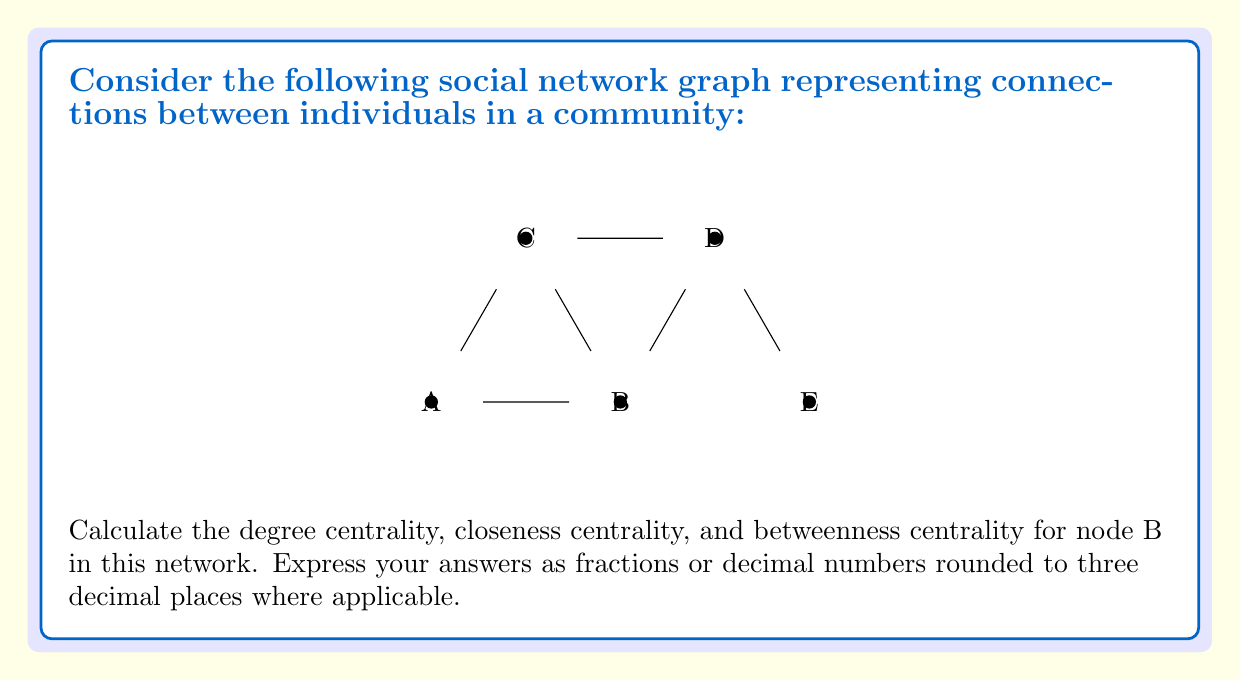Solve this math problem. To calculate the centrality measures for node B, we'll follow these steps:

1. Degree Centrality:
   Degree centrality is the number of direct connections a node has.
   Node B has 3 connections (to A, C, and D).
   Degree centrality = 3
   Normalized degree centrality = $\frac{3}{n-1} = \frac{3}{4} = 0.75$, where n is the total number of nodes (5).

2. Closeness Centrality:
   Closeness centrality measures how close a node is to all other nodes in the network.
   First, calculate the shortest path lengths from B to all other nodes:
   B to A: 1
   B to C: 1
   B to D: 1
   B to E: 2
   Sum of shortest paths = 1 + 1 + 1 + 2 = 5
   Closeness centrality = $\frac{1}{\text{sum of shortest paths}} = \frac{1}{5} = 0.2$
   Normalized closeness centrality = $\frac{n-1}{\text{sum of shortest paths}} = \frac{4}{5} = 0.8$

3. Betweenness Centrality:
   Betweenness centrality measures how often a node appears on the shortest paths between other nodes.
   For each pair of nodes (excluding B), count how many shortest paths pass through B:
   A-C: 0 (direct connection)
   A-D: 1 (through B)
   A-E: 1 (through B)
   C-D: 0 (direct connection)
   C-E: 1 (through B)
   D-E: 0 (direct connection)
   Total: 3
   Betweenness centrality = 3
   Normalized betweenness centrality = $\frac{3}{\frac{(n-1)(n-2)}{2}} = \frac{3}{6} = 0.5$
Answer: Degree centrality: 0.750
Closeness centrality: 0.800
Betweenness centrality: 0.500 